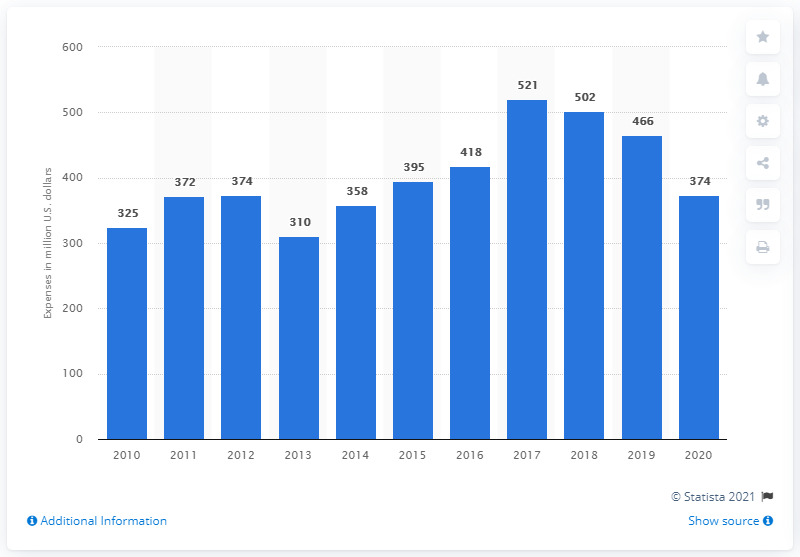Highlight a few significant elements in this photo. General Dynamics Corporation spent a total of $374 million on company-sponsored research and development costs between 2010 and 2020. In 2010, General Dynamics Corporation incurred company-sponsored research and development expenses. 